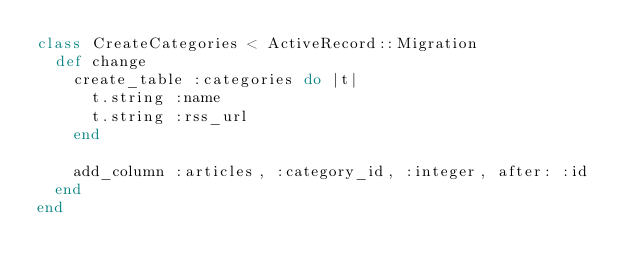<code> <loc_0><loc_0><loc_500><loc_500><_Ruby_>class CreateCategories < ActiveRecord::Migration
  def change
    create_table :categories do |t|
      t.string :name
      t.string :rss_url
    end

    add_column :articles, :category_id, :integer, after: :id
  end
end
</code> 